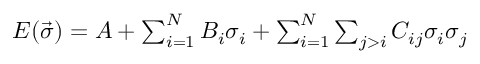<formula> <loc_0><loc_0><loc_500><loc_500>\begin{array} { r } { E ( \vec { \sigma } ) = A + \sum _ { i = 1 } ^ { N } B _ { i } \sigma _ { i } + \sum _ { i = 1 } ^ { N } \sum _ { j > i } C _ { i j } \sigma _ { i } \sigma _ { j } } \end{array}</formula> 